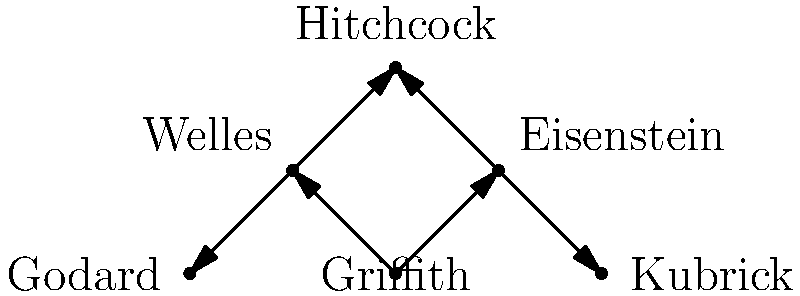In the influence network of major film directors shown above, which director has the highest out-degree centrality, and what does this suggest about their role in film history? To answer this question, we need to follow these steps:

1. Understand out-degree centrality:
   Out-degree centrality is the number of outgoing connections (arrows) from a node in a directed graph.

2. Count the outgoing connections for each director:
   - Griffith: 2 (to Eisenstein and Welles)
   - Eisenstein: 2 (to Hitchcock and Kubrick)
   - Welles: 2 (to Hitchcock and Godard)
   - Hitchcock: 2 (to Kubrick and Godard)
   - Kubrick: 0
   - Godard: 0

3. Identify the highest out-degree centrality:
   Griffith, Eisenstein, Welles, and Hitchcock all have an out-degree of 2, which is the highest in this network.

4. Interpret the result:
   The highest out-degree centrality suggests that these directors had the most direct influence on other major directors in the network. In this case, Griffith stands out as he is at the root of the influence tree, indicating he was an early pioneer whose work influenced subsequent generations of filmmakers.

5. Historical context:
   D.W. Griffith is often considered the "Father of Film" due to his innovative techniques in early cinema, particularly in the silent film era. His work laid the foundation for many cinematic conventions and influenced directors across different periods and movements.
Answer: D.W. Griffith; pioneering influence in early cinema 